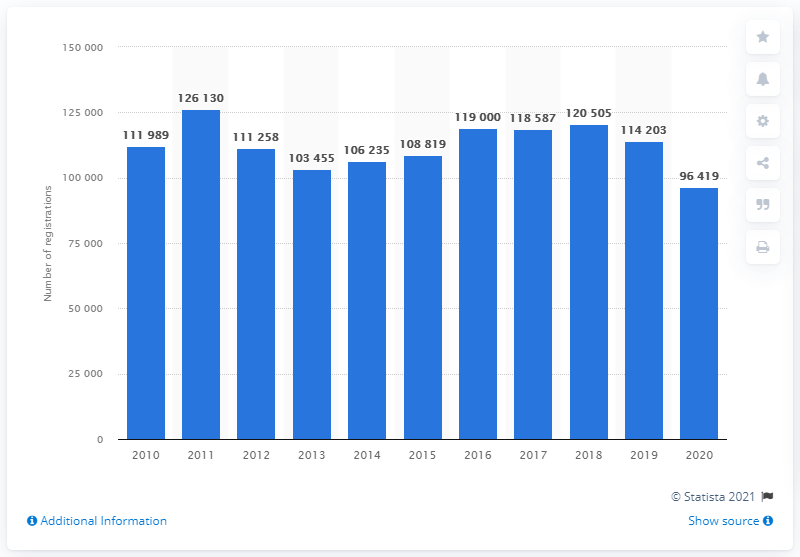Specify some key components in this picture. In 2020, a total of 96,419 passenger cars were registered. Passenger car registrations will come to an end in Finland in the year 2020. 